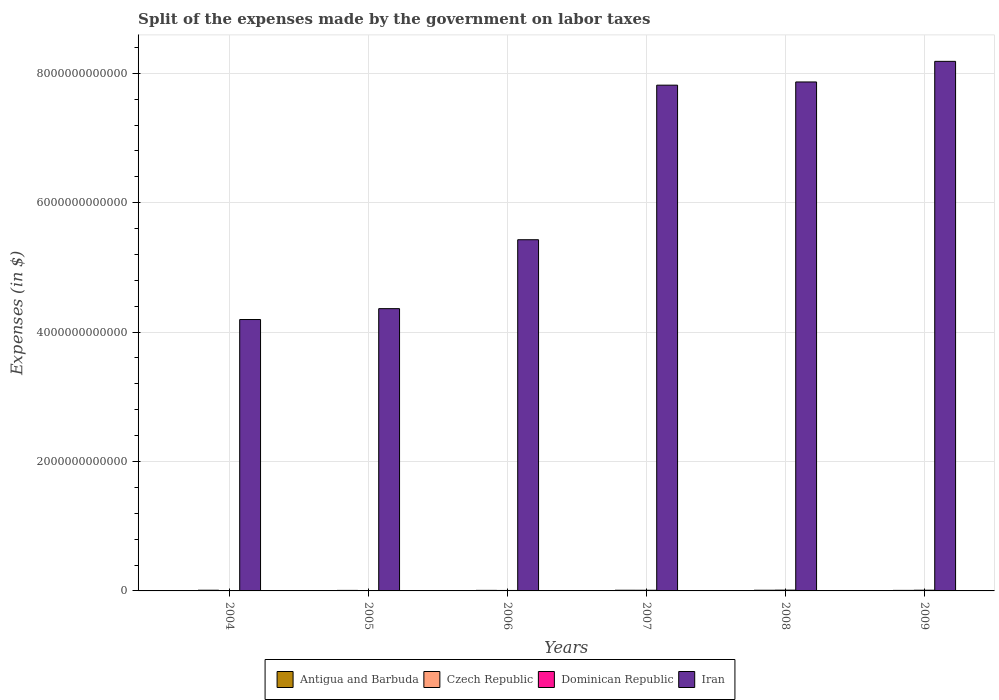How many different coloured bars are there?
Offer a very short reply. 4. How many groups of bars are there?
Provide a succinct answer. 6. Are the number of bars per tick equal to the number of legend labels?
Provide a succinct answer. Yes. How many bars are there on the 3rd tick from the left?
Give a very brief answer. 4. How many bars are there on the 6th tick from the right?
Provide a succinct answer. 4. What is the label of the 2nd group of bars from the left?
Provide a succinct answer. 2005. In how many cases, is the number of bars for a given year not equal to the number of legend labels?
Keep it short and to the point. 0. What is the expenses made by the government on labor taxes in Antigua and Barbuda in 2004?
Ensure brevity in your answer.  1.00e+07. Across all years, what is the maximum expenses made by the government on labor taxes in Antigua and Barbuda?
Your response must be concise. 1.49e+07. Across all years, what is the minimum expenses made by the government on labor taxes in Czech Republic?
Provide a short and direct response. 8.15e+09. What is the total expenses made by the government on labor taxes in Dominican Republic in the graph?
Your response must be concise. 4.66e+1. What is the difference between the expenses made by the government on labor taxes in Czech Republic in 2004 and that in 2007?
Offer a very short reply. 6.90e+07. What is the difference between the expenses made by the government on labor taxes in Czech Republic in 2007 and the expenses made by the government on labor taxes in Antigua and Barbuda in 2005?
Your answer should be compact. 1.06e+1. What is the average expenses made by the government on labor taxes in Iran per year?
Keep it short and to the point. 6.31e+12. In the year 2008, what is the difference between the expenses made by the government on labor taxes in Iran and expenses made by the government on labor taxes in Antigua and Barbuda?
Offer a very short reply. 7.87e+12. What is the ratio of the expenses made by the government on labor taxes in Iran in 2006 to that in 2009?
Provide a short and direct response. 0.66. Is the expenses made by the government on labor taxes in Czech Republic in 2007 less than that in 2009?
Ensure brevity in your answer.  No. What is the difference between the highest and the second highest expenses made by the government on labor taxes in Dominican Republic?
Your answer should be very brief. 1.29e+09. In how many years, is the expenses made by the government on labor taxes in Antigua and Barbuda greater than the average expenses made by the government on labor taxes in Antigua and Barbuda taken over all years?
Ensure brevity in your answer.  2. Is it the case that in every year, the sum of the expenses made by the government on labor taxes in Czech Republic and expenses made by the government on labor taxes in Antigua and Barbuda is greater than the sum of expenses made by the government on labor taxes in Dominican Republic and expenses made by the government on labor taxes in Iran?
Provide a short and direct response. Yes. What does the 2nd bar from the left in 2004 represents?
Keep it short and to the point. Czech Republic. What does the 2nd bar from the right in 2008 represents?
Your response must be concise. Dominican Republic. Is it the case that in every year, the sum of the expenses made by the government on labor taxes in Czech Republic and expenses made by the government on labor taxes in Iran is greater than the expenses made by the government on labor taxes in Antigua and Barbuda?
Keep it short and to the point. Yes. Are all the bars in the graph horizontal?
Your answer should be compact. No. How many years are there in the graph?
Offer a terse response. 6. What is the difference between two consecutive major ticks on the Y-axis?
Make the answer very short. 2.00e+12. Are the values on the major ticks of Y-axis written in scientific E-notation?
Offer a terse response. No. Does the graph contain any zero values?
Give a very brief answer. No. Where does the legend appear in the graph?
Your answer should be very brief. Bottom center. What is the title of the graph?
Give a very brief answer. Split of the expenses made by the government on labor taxes. What is the label or title of the X-axis?
Your response must be concise. Years. What is the label or title of the Y-axis?
Ensure brevity in your answer.  Expenses (in $). What is the Expenses (in $) in Antigua and Barbuda in 2004?
Provide a succinct answer. 1.00e+07. What is the Expenses (in $) of Czech Republic in 2004?
Your answer should be compact. 1.07e+1. What is the Expenses (in $) of Dominican Republic in 2004?
Offer a terse response. 2.13e+09. What is the Expenses (in $) in Iran in 2004?
Provide a succinct answer. 4.19e+12. What is the Expenses (in $) of Antigua and Barbuda in 2005?
Ensure brevity in your answer.  1.05e+07. What is the Expenses (in $) in Czech Republic in 2005?
Give a very brief answer. 8.15e+09. What is the Expenses (in $) in Dominican Republic in 2005?
Your response must be concise. 3.90e+09. What is the Expenses (in $) of Iran in 2005?
Your answer should be very brief. 4.36e+12. What is the Expenses (in $) of Antigua and Barbuda in 2006?
Give a very brief answer. 1.13e+07. What is the Expenses (in $) in Czech Republic in 2006?
Make the answer very short. 8.54e+09. What is the Expenses (in $) in Dominican Republic in 2006?
Offer a terse response. 7.19e+09. What is the Expenses (in $) of Iran in 2006?
Give a very brief answer. 5.43e+12. What is the Expenses (in $) in Antigua and Barbuda in 2007?
Offer a very short reply. 8.90e+06. What is the Expenses (in $) of Czech Republic in 2007?
Your answer should be very brief. 1.06e+1. What is the Expenses (in $) of Dominican Republic in 2007?
Keep it short and to the point. 1.04e+1. What is the Expenses (in $) of Iran in 2007?
Your answer should be compact. 7.82e+12. What is the Expenses (in $) in Antigua and Barbuda in 2008?
Your response must be concise. 1.41e+07. What is the Expenses (in $) in Czech Republic in 2008?
Provide a succinct answer. 1.04e+1. What is the Expenses (in $) in Dominican Republic in 2008?
Your answer should be compact. 1.22e+1. What is the Expenses (in $) of Iran in 2008?
Provide a short and direct response. 7.87e+12. What is the Expenses (in $) of Antigua and Barbuda in 2009?
Ensure brevity in your answer.  1.49e+07. What is the Expenses (in $) of Czech Republic in 2009?
Keep it short and to the point. 8.24e+09. What is the Expenses (in $) in Dominican Republic in 2009?
Provide a succinct answer. 1.09e+1. What is the Expenses (in $) of Iran in 2009?
Provide a short and direct response. 8.18e+12. Across all years, what is the maximum Expenses (in $) in Antigua and Barbuda?
Your answer should be compact. 1.49e+07. Across all years, what is the maximum Expenses (in $) in Czech Republic?
Your answer should be very brief. 1.07e+1. Across all years, what is the maximum Expenses (in $) in Dominican Republic?
Your answer should be very brief. 1.22e+1. Across all years, what is the maximum Expenses (in $) of Iran?
Your answer should be very brief. 8.18e+12. Across all years, what is the minimum Expenses (in $) of Antigua and Barbuda?
Make the answer very short. 8.90e+06. Across all years, what is the minimum Expenses (in $) of Czech Republic?
Your answer should be compact. 8.15e+09. Across all years, what is the minimum Expenses (in $) in Dominican Republic?
Keep it short and to the point. 2.13e+09. Across all years, what is the minimum Expenses (in $) of Iran?
Make the answer very short. 4.19e+12. What is the total Expenses (in $) in Antigua and Barbuda in the graph?
Ensure brevity in your answer.  6.97e+07. What is the total Expenses (in $) of Czech Republic in the graph?
Your response must be concise. 5.66e+1. What is the total Expenses (in $) of Dominican Republic in the graph?
Your answer should be compact. 4.66e+1. What is the total Expenses (in $) in Iran in the graph?
Your response must be concise. 3.79e+13. What is the difference between the Expenses (in $) of Antigua and Barbuda in 2004 and that in 2005?
Your answer should be very brief. -5.00e+05. What is the difference between the Expenses (in $) in Czech Republic in 2004 and that in 2005?
Your answer should be very brief. 2.52e+09. What is the difference between the Expenses (in $) of Dominican Republic in 2004 and that in 2005?
Give a very brief answer. -1.76e+09. What is the difference between the Expenses (in $) of Iran in 2004 and that in 2005?
Provide a succinct answer. -1.68e+11. What is the difference between the Expenses (in $) of Antigua and Barbuda in 2004 and that in 2006?
Your response must be concise. -1.30e+06. What is the difference between the Expenses (in $) of Czech Republic in 2004 and that in 2006?
Give a very brief answer. 2.13e+09. What is the difference between the Expenses (in $) of Dominican Republic in 2004 and that in 2006?
Provide a succinct answer. -5.05e+09. What is the difference between the Expenses (in $) in Iran in 2004 and that in 2006?
Provide a short and direct response. -1.23e+12. What is the difference between the Expenses (in $) in Antigua and Barbuda in 2004 and that in 2007?
Provide a short and direct response. 1.10e+06. What is the difference between the Expenses (in $) in Czech Republic in 2004 and that in 2007?
Give a very brief answer. 6.90e+07. What is the difference between the Expenses (in $) of Dominican Republic in 2004 and that in 2007?
Make the answer very short. -8.23e+09. What is the difference between the Expenses (in $) in Iran in 2004 and that in 2007?
Offer a terse response. -3.62e+12. What is the difference between the Expenses (in $) of Antigua and Barbuda in 2004 and that in 2008?
Offer a terse response. -4.10e+06. What is the difference between the Expenses (in $) in Czech Republic in 2004 and that in 2008?
Your answer should be very brief. 2.58e+08. What is the difference between the Expenses (in $) in Dominican Republic in 2004 and that in 2008?
Provide a short and direct response. -1.00e+1. What is the difference between the Expenses (in $) in Iran in 2004 and that in 2008?
Your response must be concise. -3.67e+12. What is the difference between the Expenses (in $) in Antigua and Barbuda in 2004 and that in 2009?
Provide a short and direct response. -4.90e+06. What is the difference between the Expenses (in $) of Czech Republic in 2004 and that in 2009?
Make the answer very short. 2.43e+09. What is the difference between the Expenses (in $) of Dominican Republic in 2004 and that in 2009?
Keep it short and to the point. -8.75e+09. What is the difference between the Expenses (in $) in Iran in 2004 and that in 2009?
Your response must be concise. -3.99e+12. What is the difference between the Expenses (in $) of Antigua and Barbuda in 2005 and that in 2006?
Your answer should be very brief. -8.00e+05. What is the difference between the Expenses (in $) of Czech Republic in 2005 and that in 2006?
Your answer should be very brief. -3.83e+08. What is the difference between the Expenses (in $) of Dominican Republic in 2005 and that in 2006?
Your response must be concise. -3.29e+09. What is the difference between the Expenses (in $) in Iran in 2005 and that in 2006?
Your answer should be compact. -1.07e+12. What is the difference between the Expenses (in $) in Antigua and Barbuda in 2005 and that in 2007?
Your answer should be compact. 1.60e+06. What is the difference between the Expenses (in $) in Czech Republic in 2005 and that in 2007?
Your response must be concise. -2.45e+09. What is the difference between the Expenses (in $) in Dominican Republic in 2005 and that in 2007?
Your answer should be compact. -6.46e+09. What is the difference between the Expenses (in $) in Iran in 2005 and that in 2007?
Offer a terse response. -3.45e+12. What is the difference between the Expenses (in $) of Antigua and Barbuda in 2005 and that in 2008?
Provide a succinct answer. -3.60e+06. What is the difference between the Expenses (in $) in Czech Republic in 2005 and that in 2008?
Your response must be concise. -2.26e+09. What is the difference between the Expenses (in $) of Dominican Republic in 2005 and that in 2008?
Your response must be concise. -8.28e+09. What is the difference between the Expenses (in $) of Iran in 2005 and that in 2008?
Offer a terse response. -3.50e+12. What is the difference between the Expenses (in $) of Antigua and Barbuda in 2005 and that in 2009?
Make the answer very short. -4.40e+06. What is the difference between the Expenses (in $) of Czech Republic in 2005 and that in 2009?
Give a very brief answer. -8.60e+07. What is the difference between the Expenses (in $) in Dominican Republic in 2005 and that in 2009?
Your response must be concise. -6.98e+09. What is the difference between the Expenses (in $) of Iran in 2005 and that in 2009?
Your answer should be compact. -3.82e+12. What is the difference between the Expenses (in $) in Antigua and Barbuda in 2006 and that in 2007?
Offer a very short reply. 2.40e+06. What is the difference between the Expenses (in $) in Czech Republic in 2006 and that in 2007?
Ensure brevity in your answer.  -2.06e+09. What is the difference between the Expenses (in $) of Dominican Republic in 2006 and that in 2007?
Offer a terse response. -3.17e+09. What is the difference between the Expenses (in $) of Iran in 2006 and that in 2007?
Give a very brief answer. -2.39e+12. What is the difference between the Expenses (in $) of Antigua and Barbuda in 2006 and that in 2008?
Offer a terse response. -2.80e+06. What is the difference between the Expenses (in $) of Czech Republic in 2006 and that in 2008?
Give a very brief answer. -1.88e+09. What is the difference between the Expenses (in $) in Dominican Republic in 2006 and that in 2008?
Your response must be concise. -4.99e+09. What is the difference between the Expenses (in $) in Iran in 2006 and that in 2008?
Make the answer very short. -2.44e+12. What is the difference between the Expenses (in $) in Antigua and Barbuda in 2006 and that in 2009?
Your response must be concise. -3.60e+06. What is the difference between the Expenses (in $) in Czech Republic in 2006 and that in 2009?
Keep it short and to the point. 2.97e+08. What is the difference between the Expenses (in $) in Dominican Republic in 2006 and that in 2009?
Ensure brevity in your answer.  -3.69e+09. What is the difference between the Expenses (in $) in Iran in 2006 and that in 2009?
Your answer should be compact. -2.76e+12. What is the difference between the Expenses (in $) in Antigua and Barbuda in 2007 and that in 2008?
Your answer should be very brief. -5.20e+06. What is the difference between the Expenses (in $) of Czech Republic in 2007 and that in 2008?
Ensure brevity in your answer.  1.89e+08. What is the difference between the Expenses (in $) in Dominican Republic in 2007 and that in 2008?
Make the answer very short. -1.81e+09. What is the difference between the Expenses (in $) in Iran in 2007 and that in 2008?
Give a very brief answer. -4.96e+1. What is the difference between the Expenses (in $) in Antigua and Barbuda in 2007 and that in 2009?
Provide a succinct answer. -6.00e+06. What is the difference between the Expenses (in $) in Czech Republic in 2007 and that in 2009?
Ensure brevity in your answer.  2.36e+09. What is the difference between the Expenses (in $) in Dominican Republic in 2007 and that in 2009?
Your response must be concise. -5.21e+08. What is the difference between the Expenses (in $) in Iran in 2007 and that in 2009?
Provide a short and direct response. -3.68e+11. What is the difference between the Expenses (in $) of Antigua and Barbuda in 2008 and that in 2009?
Keep it short and to the point. -8.00e+05. What is the difference between the Expenses (in $) of Czech Republic in 2008 and that in 2009?
Offer a terse response. 2.17e+09. What is the difference between the Expenses (in $) in Dominican Republic in 2008 and that in 2009?
Offer a terse response. 1.29e+09. What is the difference between the Expenses (in $) in Iran in 2008 and that in 2009?
Make the answer very short. -3.18e+11. What is the difference between the Expenses (in $) of Antigua and Barbuda in 2004 and the Expenses (in $) of Czech Republic in 2005?
Your answer should be very brief. -8.14e+09. What is the difference between the Expenses (in $) of Antigua and Barbuda in 2004 and the Expenses (in $) of Dominican Republic in 2005?
Make the answer very short. -3.89e+09. What is the difference between the Expenses (in $) of Antigua and Barbuda in 2004 and the Expenses (in $) of Iran in 2005?
Offer a terse response. -4.36e+12. What is the difference between the Expenses (in $) of Czech Republic in 2004 and the Expenses (in $) of Dominican Republic in 2005?
Offer a very short reply. 6.77e+09. What is the difference between the Expenses (in $) in Czech Republic in 2004 and the Expenses (in $) in Iran in 2005?
Make the answer very short. -4.35e+12. What is the difference between the Expenses (in $) in Dominican Republic in 2004 and the Expenses (in $) in Iran in 2005?
Provide a short and direct response. -4.36e+12. What is the difference between the Expenses (in $) of Antigua and Barbuda in 2004 and the Expenses (in $) of Czech Republic in 2006?
Make the answer very short. -8.53e+09. What is the difference between the Expenses (in $) of Antigua and Barbuda in 2004 and the Expenses (in $) of Dominican Republic in 2006?
Ensure brevity in your answer.  -7.18e+09. What is the difference between the Expenses (in $) of Antigua and Barbuda in 2004 and the Expenses (in $) of Iran in 2006?
Give a very brief answer. -5.43e+12. What is the difference between the Expenses (in $) in Czech Republic in 2004 and the Expenses (in $) in Dominican Republic in 2006?
Your answer should be compact. 3.48e+09. What is the difference between the Expenses (in $) in Czech Republic in 2004 and the Expenses (in $) in Iran in 2006?
Give a very brief answer. -5.42e+12. What is the difference between the Expenses (in $) in Dominican Republic in 2004 and the Expenses (in $) in Iran in 2006?
Your answer should be very brief. -5.43e+12. What is the difference between the Expenses (in $) of Antigua and Barbuda in 2004 and the Expenses (in $) of Czech Republic in 2007?
Offer a terse response. -1.06e+1. What is the difference between the Expenses (in $) of Antigua and Barbuda in 2004 and the Expenses (in $) of Dominican Republic in 2007?
Your answer should be very brief. -1.04e+1. What is the difference between the Expenses (in $) in Antigua and Barbuda in 2004 and the Expenses (in $) in Iran in 2007?
Keep it short and to the point. -7.82e+12. What is the difference between the Expenses (in $) of Czech Republic in 2004 and the Expenses (in $) of Dominican Republic in 2007?
Your response must be concise. 3.08e+08. What is the difference between the Expenses (in $) in Czech Republic in 2004 and the Expenses (in $) in Iran in 2007?
Make the answer very short. -7.81e+12. What is the difference between the Expenses (in $) of Dominican Republic in 2004 and the Expenses (in $) of Iran in 2007?
Your answer should be compact. -7.81e+12. What is the difference between the Expenses (in $) in Antigua and Barbuda in 2004 and the Expenses (in $) in Czech Republic in 2008?
Offer a terse response. -1.04e+1. What is the difference between the Expenses (in $) in Antigua and Barbuda in 2004 and the Expenses (in $) in Dominican Republic in 2008?
Ensure brevity in your answer.  -1.22e+1. What is the difference between the Expenses (in $) in Antigua and Barbuda in 2004 and the Expenses (in $) in Iran in 2008?
Offer a very short reply. -7.87e+12. What is the difference between the Expenses (in $) in Czech Republic in 2004 and the Expenses (in $) in Dominican Republic in 2008?
Make the answer very short. -1.51e+09. What is the difference between the Expenses (in $) in Czech Republic in 2004 and the Expenses (in $) in Iran in 2008?
Provide a succinct answer. -7.86e+12. What is the difference between the Expenses (in $) of Dominican Republic in 2004 and the Expenses (in $) of Iran in 2008?
Make the answer very short. -7.86e+12. What is the difference between the Expenses (in $) in Antigua and Barbuda in 2004 and the Expenses (in $) in Czech Republic in 2009?
Keep it short and to the point. -8.23e+09. What is the difference between the Expenses (in $) in Antigua and Barbuda in 2004 and the Expenses (in $) in Dominican Republic in 2009?
Your answer should be compact. -1.09e+1. What is the difference between the Expenses (in $) in Antigua and Barbuda in 2004 and the Expenses (in $) in Iran in 2009?
Your answer should be very brief. -8.18e+12. What is the difference between the Expenses (in $) in Czech Republic in 2004 and the Expenses (in $) in Dominican Republic in 2009?
Your answer should be very brief. -2.14e+08. What is the difference between the Expenses (in $) of Czech Republic in 2004 and the Expenses (in $) of Iran in 2009?
Provide a short and direct response. -8.17e+12. What is the difference between the Expenses (in $) in Dominican Republic in 2004 and the Expenses (in $) in Iran in 2009?
Your answer should be very brief. -8.18e+12. What is the difference between the Expenses (in $) of Antigua and Barbuda in 2005 and the Expenses (in $) of Czech Republic in 2006?
Make the answer very short. -8.53e+09. What is the difference between the Expenses (in $) of Antigua and Barbuda in 2005 and the Expenses (in $) of Dominican Republic in 2006?
Make the answer very short. -7.18e+09. What is the difference between the Expenses (in $) of Antigua and Barbuda in 2005 and the Expenses (in $) of Iran in 2006?
Give a very brief answer. -5.43e+12. What is the difference between the Expenses (in $) in Czech Republic in 2005 and the Expenses (in $) in Dominican Republic in 2006?
Provide a succinct answer. 9.64e+08. What is the difference between the Expenses (in $) in Czech Republic in 2005 and the Expenses (in $) in Iran in 2006?
Your answer should be compact. -5.42e+12. What is the difference between the Expenses (in $) in Dominican Republic in 2005 and the Expenses (in $) in Iran in 2006?
Offer a terse response. -5.42e+12. What is the difference between the Expenses (in $) in Antigua and Barbuda in 2005 and the Expenses (in $) in Czech Republic in 2007?
Your answer should be compact. -1.06e+1. What is the difference between the Expenses (in $) in Antigua and Barbuda in 2005 and the Expenses (in $) in Dominican Republic in 2007?
Ensure brevity in your answer.  -1.04e+1. What is the difference between the Expenses (in $) in Antigua and Barbuda in 2005 and the Expenses (in $) in Iran in 2007?
Your response must be concise. -7.82e+12. What is the difference between the Expenses (in $) in Czech Republic in 2005 and the Expenses (in $) in Dominican Republic in 2007?
Provide a short and direct response. -2.21e+09. What is the difference between the Expenses (in $) of Czech Republic in 2005 and the Expenses (in $) of Iran in 2007?
Offer a very short reply. -7.81e+12. What is the difference between the Expenses (in $) in Dominican Republic in 2005 and the Expenses (in $) in Iran in 2007?
Provide a short and direct response. -7.81e+12. What is the difference between the Expenses (in $) in Antigua and Barbuda in 2005 and the Expenses (in $) in Czech Republic in 2008?
Your response must be concise. -1.04e+1. What is the difference between the Expenses (in $) of Antigua and Barbuda in 2005 and the Expenses (in $) of Dominican Republic in 2008?
Provide a succinct answer. -1.22e+1. What is the difference between the Expenses (in $) in Antigua and Barbuda in 2005 and the Expenses (in $) in Iran in 2008?
Offer a terse response. -7.87e+12. What is the difference between the Expenses (in $) in Czech Republic in 2005 and the Expenses (in $) in Dominican Republic in 2008?
Provide a short and direct response. -4.02e+09. What is the difference between the Expenses (in $) in Czech Republic in 2005 and the Expenses (in $) in Iran in 2008?
Provide a succinct answer. -7.86e+12. What is the difference between the Expenses (in $) of Dominican Republic in 2005 and the Expenses (in $) of Iran in 2008?
Your answer should be compact. -7.86e+12. What is the difference between the Expenses (in $) of Antigua and Barbuda in 2005 and the Expenses (in $) of Czech Republic in 2009?
Make the answer very short. -8.23e+09. What is the difference between the Expenses (in $) of Antigua and Barbuda in 2005 and the Expenses (in $) of Dominican Republic in 2009?
Your answer should be very brief. -1.09e+1. What is the difference between the Expenses (in $) of Antigua and Barbuda in 2005 and the Expenses (in $) of Iran in 2009?
Your response must be concise. -8.18e+12. What is the difference between the Expenses (in $) in Czech Republic in 2005 and the Expenses (in $) in Dominican Republic in 2009?
Provide a short and direct response. -2.73e+09. What is the difference between the Expenses (in $) of Czech Republic in 2005 and the Expenses (in $) of Iran in 2009?
Your answer should be compact. -8.18e+12. What is the difference between the Expenses (in $) of Dominican Republic in 2005 and the Expenses (in $) of Iran in 2009?
Your answer should be very brief. -8.18e+12. What is the difference between the Expenses (in $) in Antigua and Barbuda in 2006 and the Expenses (in $) in Czech Republic in 2007?
Your answer should be very brief. -1.06e+1. What is the difference between the Expenses (in $) in Antigua and Barbuda in 2006 and the Expenses (in $) in Dominican Republic in 2007?
Your answer should be very brief. -1.04e+1. What is the difference between the Expenses (in $) in Antigua and Barbuda in 2006 and the Expenses (in $) in Iran in 2007?
Your answer should be very brief. -7.82e+12. What is the difference between the Expenses (in $) in Czech Republic in 2006 and the Expenses (in $) in Dominican Republic in 2007?
Offer a very short reply. -1.83e+09. What is the difference between the Expenses (in $) of Czech Republic in 2006 and the Expenses (in $) of Iran in 2007?
Give a very brief answer. -7.81e+12. What is the difference between the Expenses (in $) in Dominican Republic in 2006 and the Expenses (in $) in Iran in 2007?
Offer a terse response. -7.81e+12. What is the difference between the Expenses (in $) in Antigua and Barbuda in 2006 and the Expenses (in $) in Czech Republic in 2008?
Your answer should be compact. -1.04e+1. What is the difference between the Expenses (in $) of Antigua and Barbuda in 2006 and the Expenses (in $) of Dominican Republic in 2008?
Offer a very short reply. -1.22e+1. What is the difference between the Expenses (in $) of Antigua and Barbuda in 2006 and the Expenses (in $) of Iran in 2008?
Make the answer very short. -7.87e+12. What is the difference between the Expenses (in $) in Czech Republic in 2006 and the Expenses (in $) in Dominican Republic in 2008?
Ensure brevity in your answer.  -3.64e+09. What is the difference between the Expenses (in $) in Czech Republic in 2006 and the Expenses (in $) in Iran in 2008?
Your answer should be compact. -7.86e+12. What is the difference between the Expenses (in $) of Dominican Republic in 2006 and the Expenses (in $) of Iran in 2008?
Provide a short and direct response. -7.86e+12. What is the difference between the Expenses (in $) in Antigua and Barbuda in 2006 and the Expenses (in $) in Czech Republic in 2009?
Your response must be concise. -8.23e+09. What is the difference between the Expenses (in $) of Antigua and Barbuda in 2006 and the Expenses (in $) of Dominican Republic in 2009?
Ensure brevity in your answer.  -1.09e+1. What is the difference between the Expenses (in $) of Antigua and Barbuda in 2006 and the Expenses (in $) of Iran in 2009?
Your response must be concise. -8.18e+12. What is the difference between the Expenses (in $) in Czech Republic in 2006 and the Expenses (in $) in Dominican Republic in 2009?
Your response must be concise. -2.35e+09. What is the difference between the Expenses (in $) of Czech Republic in 2006 and the Expenses (in $) of Iran in 2009?
Provide a short and direct response. -8.18e+12. What is the difference between the Expenses (in $) in Dominican Republic in 2006 and the Expenses (in $) in Iran in 2009?
Give a very brief answer. -8.18e+12. What is the difference between the Expenses (in $) of Antigua and Barbuda in 2007 and the Expenses (in $) of Czech Republic in 2008?
Provide a short and direct response. -1.04e+1. What is the difference between the Expenses (in $) in Antigua and Barbuda in 2007 and the Expenses (in $) in Dominican Republic in 2008?
Keep it short and to the point. -1.22e+1. What is the difference between the Expenses (in $) of Antigua and Barbuda in 2007 and the Expenses (in $) of Iran in 2008?
Provide a succinct answer. -7.87e+12. What is the difference between the Expenses (in $) in Czech Republic in 2007 and the Expenses (in $) in Dominican Republic in 2008?
Ensure brevity in your answer.  -1.57e+09. What is the difference between the Expenses (in $) in Czech Republic in 2007 and the Expenses (in $) in Iran in 2008?
Ensure brevity in your answer.  -7.86e+12. What is the difference between the Expenses (in $) of Dominican Republic in 2007 and the Expenses (in $) of Iran in 2008?
Offer a terse response. -7.86e+12. What is the difference between the Expenses (in $) in Antigua and Barbuda in 2007 and the Expenses (in $) in Czech Republic in 2009?
Offer a very short reply. -8.23e+09. What is the difference between the Expenses (in $) of Antigua and Barbuda in 2007 and the Expenses (in $) of Dominican Republic in 2009?
Keep it short and to the point. -1.09e+1. What is the difference between the Expenses (in $) of Antigua and Barbuda in 2007 and the Expenses (in $) of Iran in 2009?
Offer a terse response. -8.18e+12. What is the difference between the Expenses (in $) in Czech Republic in 2007 and the Expenses (in $) in Dominican Republic in 2009?
Provide a short and direct response. -2.83e+08. What is the difference between the Expenses (in $) of Czech Republic in 2007 and the Expenses (in $) of Iran in 2009?
Your response must be concise. -8.17e+12. What is the difference between the Expenses (in $) of Dominican Republic in 2007 and the Expenses (in $) of Iran in 2009?
Offer a very short reply. -8.17e+12. What is the difference between the Expenses (in $) of Antigua and Barbuda in 2008 and the Expenses (in $) of Czech Republic in 2009?
Your answer should be very brief. -8.22e+09. What is the difference between the Expenses (in $) in Antigua and Barbuda in 2008 and the Expenses (in $) in Dominican Republic in 2009?
Provide a short and direct response. -1.09e+1. What is the difference between the Expenses (in $) of Antigua and Barbuda in 2008 and the Expenses (in $) of Iran in 2009?
Offer a very short reply. -8.18e+12. What is the difference between the Expenses (in $) of Czech Republic in 2008 and the Expenses (in $) of Dominican Republic in 2009?
Offer a very short reply. -4.72e+08. What is the difference between the Expenses (in $) of Czech Republic in 2008 and the Expenses (in $) of Iran in 2009?
Provide a short and direct response. -8.17e+12. What is the difference between the Expenses (in $) of Dominican Republic in 2008 and the Expenses (in $) of Iran in 2009?
Offer a terse response. -8.17e+12. What is the average Expenses (in $) in Antigua and Barbuda per year?
Your answer should be compact. 1.16e+07. What is the average Expenses (in $) of Czech Republic per year?
Your answer should be very brief. 9.43e+09. What is the average Expenses (in $) of Dominican Republic per year?
Make the answer very short. 7.77e+09. What is the average Expenses (in $) in Iran per year?
Your response must be concise. 6.31e+12. In the year 2004, what is the difference between the Expenses (in $) of Antigua and Barbuda and Expenses (in $) of Czech Republic?
Provide a succinct answer. -1.07e+1. In the year 2004, what is the difference between the Expenses (in $) in Antigua and Barbuda and Expenses (in $) in Dominican Republic?
Provide a succinct answer. -2.12e+09. In the year 2004, what is the difference between the Expenses (in $) in Antigua and Barbuda and Expenses (in $) in Iran?
Provide a short and direct response. -4.19e+12. In the year 2004, what is the difference between the Expenses (in $) of Czech Republic and Expenses (in $) of Dominican Republic?
Provide a succinct answer. 8.53e+09. In the year 2004, what is the difference between the Expenses (in $) in Czech Republic and Expenses (in $) in Iran?
Your response must be concise. -4.18e+12. In the year 2004, what is the difference between the Expenses (in $) of Dominican Republic and Expenses (in $) of Iran?
Provide a succinct answer. -4.19e+12. In the year 2005, what is the difference between the Expenses (in $) in Antigua and Barbuda and Expenses (in $) in Czech Republic?
Offer a very short reply. -8.14e+09. In the year 2005, what is the difference between the Expenses (in $) in Antigua and Barbuda and Expenses (in $) in Dominican Republic?
Make the answer very short. -3.89e+09. In the year 2005, what is the difference between the Expenses (in $) in Antigua and Barbuda and Expenses (in $) in Iran?
Offer a terse response. -4.36e+12. In the year 2005, what is the difference between the Expenses (in $) in Czech Republic and Expenses (in $) in Dominican Republic?
Provide a short and direct response. 4.25e+09. In the year 2005, what is the difference between the Expenses (in $) in Czech Republic and Expenses (in $) in Iran?
Your response must be concise. -4.35e+12. In the year 2005, what is the difference between the Expenses (in $) of Dominican Republic and Expenses (in $) of Iran?
Your response must be concise. -4.36e+12. In the year 2006, what is the difference between the Expenses (in $) in Antigua and Barbuda and Expenses (in $) in Czech Republic?
Ensure brevity in your answer.  -8.52e+09. In the year 2006, what is the difference between the Expenses (in $) of Antigua and Barbuda and Expenses (in $) of Dominican Republic?
Your answer should be very brief. -7.18e+09. In the year 2006, what is the difference between the Expenses (in $) of Antigua and Barbuda and Expenses (in $) of Iran?
Provide a short and direct response. -5.43e+12. In the year 2006, what is the difference between the Expenses (in $) in Czech Republic and Expenses (in $) in Dominican Republic?
Your answer should be compact. 1.35e+09. In the year 2006, what is the difference between the Expenses (in $) of Czech Republic and Expenses (in $) of Iran?
Your answer should be compact. -5.42e+12. In the year 2006, what is the difference between the Expenses (in $) of Dominican Republic and Expenses (in $) of Iran?
Your response must be concise. -5.42e+12. In the year 2007, what is the difference between the Expenses (in $) of Antigua and Barbuda and Expenses (in $) of Czech Republic?
Your answer should be compact. -1.06e+1. In the year 2007, what is the difference between the Expenses (in $) of Antigua and Barbuda and Expenses (in $) of Dominican Republic?
Ensure brevity in your answer.  -1.04e+1. In the year 2007, what is the difference between the Expenses (in $) of Antigua and Barbuda and Expenses (in $) of Iran?
Your answer should be compact. -7.82e+12. In the year 2007, what is the difference between the Expenses (in $) of Czech Republic and Expenses (in $) of Dominican Republic?
Offer a terse response. 2.39e+08. In the year 2007, what is the difference between the Expenses (in $) of Czech Republic and Expenses (in $) of Iran?
Keep it short and to the point. -7.81e+12. In the year 2007, what is the difference between the Expenses (in $) in Dominican Republic and Expenses (in $) in Iran?
Your answer should be very brief. -7.81e+12. In the year 2008, what is the difference between the Expenses (in $) of Antigua and Barbuda and Expenses (in $) of Czech Republic?
Provide a short and direct response. -1.04e+1. In the year 2008, what is the difference between the Expenses (in $) in Antigua and Barbuda and Expenses (in $) in Dominican Republic?
Ensure brevity in your answer.  -1.22e+1. In the year 2008, what is the difference between the Expenses (in $) in Antigua and Barbuda and Expenses (in $) in Iran?
Your answer should be very brief. -7.87e+12. In the year 2008, what is the difference between the Expenses (in $) of Czech Republic and Expenses (in $) of Dominican Republic?
Give a very brief answer. -1.76e+09. In the year 2008, what is the difference between the Expenses (in $) in Czech Republic and Expenses (in $) in Iran?
Your response must be concise. -7.86e+12. In the year 2008, what is the difference between the Expenses (in $) in Dominican Republic and Expenses (in $) in Iran?
Give a very brief answer. -7.85e+12. In the year 2009, what is the difference between the Expenses (in $) in Antigua and Barbuda and Expenses (in $) in Czech Republic?
Offer a very short reply. -8.22e+09. In the year 2009, what is the difference between the Expenses (in $) of Antigua and Barbuda and Expenses (in $) of Dominican Republic?
Provide a succinct answer. -1.09e+1. In the year 2009, what is the difference between the Expenses (in $) of Antigua and Barbuda and Expenses (in $) of Iran?
Provide a short and direct response. -8.18e+12. In the year 2009, what is the difference between the Expenses (in $) of Czech Republic and Expenses (in $) of Dominican Republic?
Ensure brevity in your answer.  -2.64e+09. In the year 2009, what is the difference between the Expenses (in $) in Czech Republic and Expenses (in $) in Iran?
Give a very brief answer. -8.18e+12. In the year 2009, what is the difference between the Expenses (in $) of Dominican Republic and Expenses (in $) of Iran?
Offer a very short reply. -8.17e+12. What is the ratio of the Expenses (in $) in Antigua and Barbuda in 2004 to that in 2005?
Provide a succinct answer. 0.95. What is the ratio of the Expenses (in $) in Czech Republic in 2004 to that in 2005?
Provide a succinct answer. 1.31. What is the ratio of the Expenses (in $) of Dominican Republic in 2004 to that in 2005?
Make the answer very short. 0.55. What is the ratio of the Expenses (in $) of Iran in 2004 to that in 2005?
Provide a succinct answer. 0.96. What is the ratio of the Expenses (in $) in Antigua and Barbuda in 2004 to that in 2006?
Your response must be concise. 0.89. What is the ratio of the Expenses (in $) in Czech Republic in 2004 to that in 2006?
Ensure brevity in your answer.  1.25. What is the ratio of the Expenses (in $) in Dominican Republic in 2004 to that in 2006?
Keep it short and to the point. 0.3. What is the ratio of the Expenses (in $) of Iran in 2004 to that in 2006?
Keep it short and to the point. 0.77. What is the ratio of the Expenses (in $) of Antigua and Barbuda in 2004 to that in 2007?
Your response must be concise. 1.12. What is the ratio of the Expenses (in $) of Czech Republic in 2004 to that in 2007?
Make the answer very short. 1.01. What is the ratio of the Expenses (in $) of Dominican Republic in 2004 to that in 2007?
Give a very brief answer. 0.21. What is the ratio of the Expenses (in $) of Iran in 2004 to that in 2007?
Provide a short and direct response. 0.54. What is the ratio of the Expenses (in $) in Antigua and Barbuda in 2004 to that in 2008?
Your response must be concise. 0.71. What is the ratio of the Expenses (in $) in Czech Republic in 2004 to that in 2008?
Your answer should be compact. 1.02. What is the ratio of the Expenses (in $) in Dominican Republic in 2004 to that in 2008?
Keep it short and to the point. 0.18. What is the ratio of the Expenses (in $) in Iran in 2004 to that in 2008?
Offer a very short reply. 0.53. What is the ratio of the Expenses (in $) in Antigua and Barbuda in 2004 to that in 2009?
Make the answer very short. 0.67. What is the ratio of the Expenses (in $) of Czech Republic in 2004 to that in 2009?
Offer a terse response. 1.29. What is the ratio of the Expenses (in $) in Dominican Republic in 2004 to that in 2009?
Your answer should be compact. 0.2. What is the ratio of the Expenses (in $) in Iran in 2004 to that in 2009?
Your answer should be compact. 0.51. What is the ratio of the Expenses (in $) of Antigua and Barbuda in 2005 to that in 2006?
Offer a very short reply. 0.93. What is the ratio of the Expenses (in $) of Czech Republic in 2005 to that in 2006?
Keep it short and to the point. 0.96. What is the ratio of the Expenses (in $) in Dominican Republic in 2005 to that in 2006?
Give a very brief answer. 0.54. What is the ratio of the Expenses (in $) of Iran in 2005 to that in 2006?
Ensure brevity in your answer.  0.8. What is the ratio of the Expenses (in $) of Antigua and Barbuda in 2005 to that in 2007?
Your answer should be compact. 1.18. What is the ratio of the Expenses (in $) in Czech Republic in 2005 to that in 2007?
Your answer should be very brief. 0.77. What is the ratio of the Expenses (in $) in Dominican Republic in 2005 to that in 2007?
Offer a very short reply. 0.38. What is the ratio of the Expenses (in $) in Iran in 2005 to that in 2007?
Your answer should be compact. 0.56. What is the ratio of the Expenses (in $) of Antigua and Barbuda in 2005 to that in 2008?
Your response must be concise. 0.74. What is the ratio of the Expenses (in $) in Czech Republic in 2005 to that in 2008?
Your answer should be compact. 0.78. What is the ratio of the Expenses (in $) in Dominican Republic in 2005 to that in 2008?
Make the answer very short. 0.32. What is the ratio of the Expenses (in $) in Iran in 2005 to that in 2008?
Make the answer very short. 0.55. What is the ratio of the Expenses (in $) in Antigua and Barbuda in 2005 to that in 2009?
Provide a short and direct response. 0.7. What is the ratio of the Expenses (in $) in Dominican Republic in 2005 to that in 2009?
Your response must be concise. 0.36. What is the ratio of the Expenses (in $) of Iran in 2005 to that in 2009?
Keep it short and to the point. 0.53. What is the ratio of the Expenses (in $) of Antigua and Barbuda in 2006 to that in 2007?
Ensure brevity in your answer.  1.27. What is the ratio of the Expenses (in $) in Czech Republic in 2006 to that in 2007?
Offer a very short reply. 0.81. What is the ratio of the Expenses (in $) in Dominican Republic in 2006 to that in 2007?
Provide a short and direct response. 0.69. What is the ratio of the Expenses (in $) in Iran in 2006 to that in 2007?
Give a very brief answer. 0.69. What is the ratio of the Expenses (in $) in Antigua and Barbuda in 2006 to that in 2008?
Provide a succinct answer. 0.8. What is the ratio of the Expenses (in $) in Czech Republic in 2006 to that in 2008?
Make the answer very short. 0.82. What is the ratio of the Expenses (in $) in Dominican Republic in 2006 to that in 2008?
Keep it short and to the point. 0.59. What is the ratio of the Expenses (in $) in Iran in 2006 to that in 2008?
Your answer should be very brief. 0.69. What is the ratio of the Expenses (in $) of Antigua and Barbuda in 2006 to that in 2009?
Ensure brevity in your answer.  0.76. What is the ratio of the Expenses (in $) in Czech Republic in 2006 to that in 2009?
Provide a short and direct response. 1.04. What is the ratio of the Expenses (in $) in Dominican Republic in 2006 to that in 2009?
Provide a short and direct response. 0.66. What is the ratio of the Expenses (in $) of Iran in 2006 to that in 2009?
Your answer should be compact. 0.66. What is the ratio of the Expenses (in $) in Antigua and Barbuda in 2007 to that in 2008?
Your answer should be compact. 0.63. What is the ratio of the Expenses (in $) in Czech Republic in 2007 to that in 2008?
Your answer should be very brief. 1.02. What is the ratio of the Expenses (in $) in Dominican Republic in 2007 to that in 2008?
Keep it short and to the point. 0.85. What is the ratio of the Expenses (in $) in Iran in 2007 to that in 2008?
Provide a succinct answer. 0.99. What is the ratio of the Expenses (in $) in Antigua and Barbuda in 2007 to that in 2009?
Your answer should be compact. 0.6. What is the ratio of the Expenses (in $) in Czech Republic in 2007 to that in 2009?
Your response must be concise. 1.29. What is the ratio of the Expenses (in $) of Dominican Republic in 2007 to that in 2009?
Ensure brevity in your answer.  0.95. What is the ratio of the Expenses (in $) of Iran in 2007 to that in 2009?
Offer a terse response. 0.95. What is the ratio of the Expenses (in $) of Antigua and Barbuda in 2008 to that in 2009?
Provide a short and direct response. 0.95. What is the ratio of the Expenses (in $) of Czech Republic in 2008 to that in 2009?
Ensure brevity in your answer.  1.26. What is the ratio of the Expenses (in $) in Dominican Republic in 2008 to that in 2009?
Make the answer very short. 1.12. What is the ratio of the Expenses (in $) in Iran in 2008 to that in 2009?
Your answer should be very brief. 0.96. What is the difference between the highest and the second highest Expenses (in $) in Czech Republic?
Keep it short and to the point. 6.90e+07. What is the difference between the highest and the second highest Expenses (in $) in Dominican Republic?
Offer a terse response. 1.29e+09. What is the difference between the highest and the second highest Expenses (in $) of Iran?
Your response must be concise. 3.18e+11. What is the difference between the highest and the lowest Expenses (in $) of Czech Republic?
Offer a terse response. 2.52e+09. What is the difference between the highest and the lowest Expenses (in $) in Dominican Republic?
Give a very brief answer. 1.00e+1. What is the difference between the highest and the lowest Expenses (in $) in Iran?
Your answer should be very brief. 3.99e+12. 